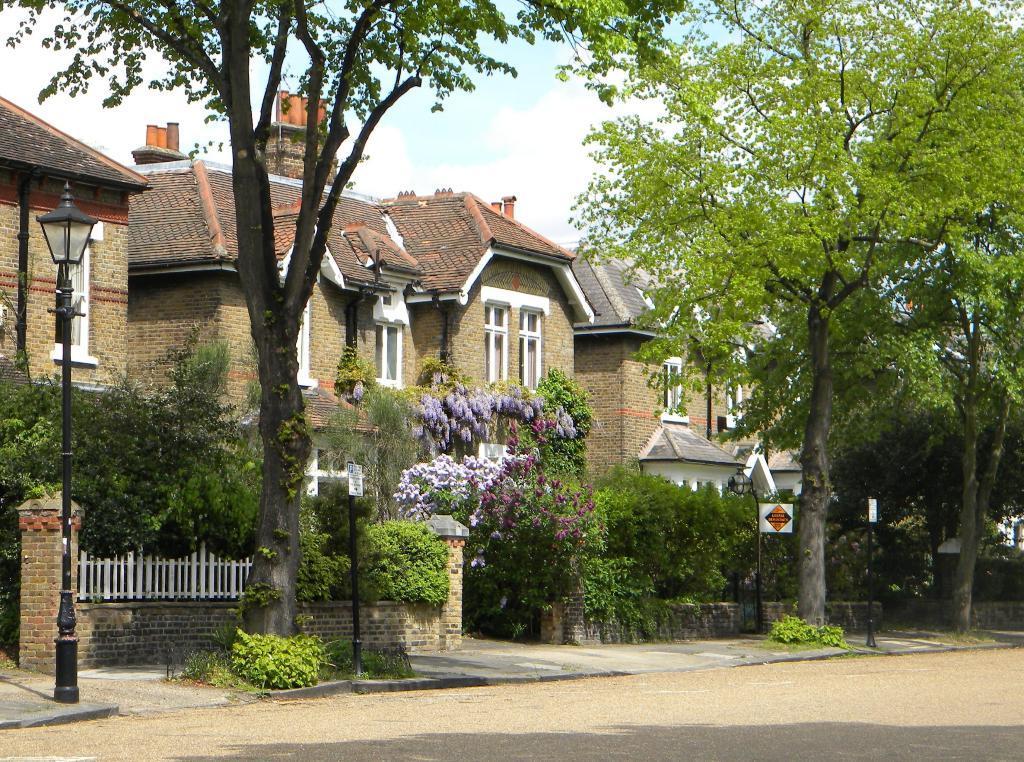Please provide a concise description of this image. In this image there is the sky, there are houses, there are trees, there is a wall, there are poles, there are boards on the poles, there are plants, there is a streetlight, there are windows, there is the road. 